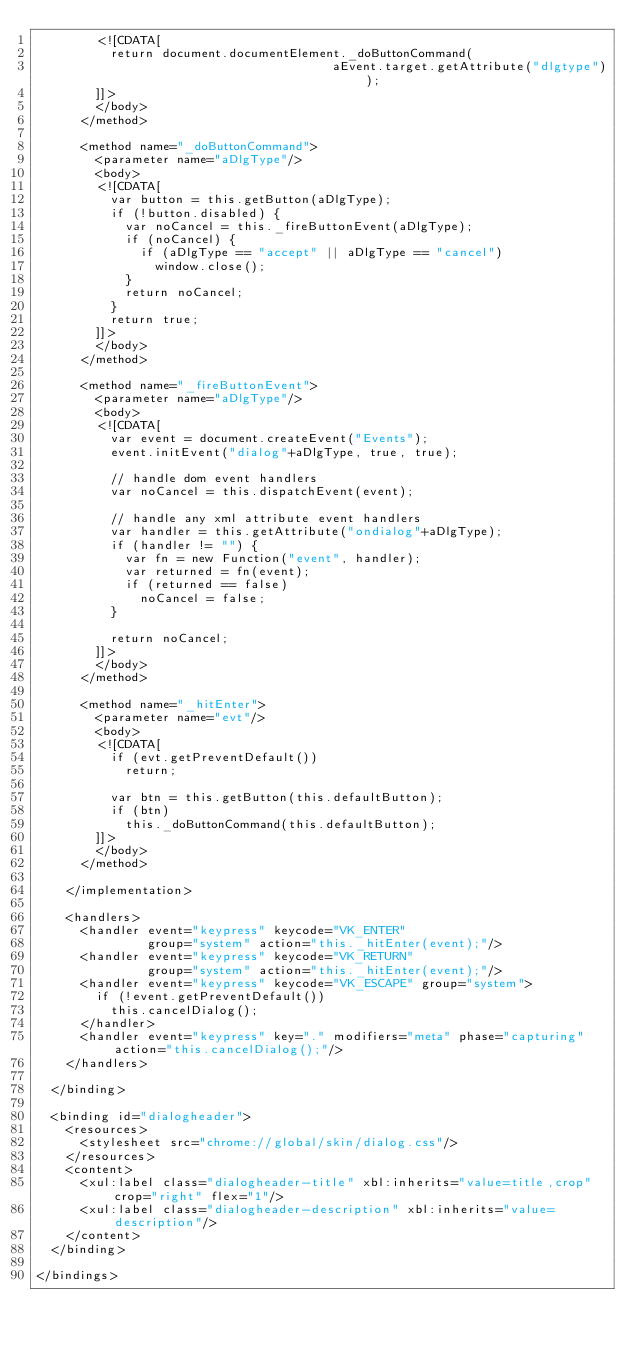Convert code to text. <code><loc_0><loc_0><loc_500><loc_500><_XML_>        <![CDATA[
          return document.documentElement._doButtonCommand(
                                        aEvent.target.getAttribute("dlgtype"));
        ]]>
        </body>
      </method>
      
      <method name="_doButtonCommand">
        <parameter name="aDlgType"/>
        <body>
        <![CDATA[
          var button = this.getButton(aDlgType);
          if (!button.disabled) {
            var noCancel = this._fireButtonEvent(aDlgType);
            if (noCancel) {
              if (aDlgType == "accept" || aDlgType == "cancel")
                window.close();
            }
            return noCancel;
          }
          return true;
        ]]>
        </body>
      </method>
      
      <method name="_fireButtonEvent">
        <parameter name="aDlgType"/>
        <body>
        <![CDATA[
          var event = document.createEvent("Events");
          event.initEvent("dialog"+aDlgType, true, true);
          
          // handle dom event handlers
          var noCancel = this.dispatchEvent(event);
          
          // handle any xml attribute event handlers
          var handler = this.getAttribute("ondialog"+aDlgType);
          if (handler != "") {
            var fn = new Function("event", handler);
            var returned = fn(event);
            if (returned == false)
              noCancel = false;
          }
          
          return noCancel;
        ]]>
        </body>
      </method>

      <method name="_hitEnter">
        <parameter name="evt"/>
        <body>
        <![CDATA[
          if (evt.getPreventDefault())
            return;

          var btn = this.getButton(this.defaultButton);
          if (btn)
            this._doButtonCommand(this.defaultButton);
        ]]>
        </body>
      </method>

    </implementation>
    
    <handlers>
      <handler event="keypress" keycode="VK_ENTER"
               group="system" action="this._hitEnter(event);"/>
      <handler event="keypress" keycode="VK_RETURN"
               group="system" action="this._hitEnter(event);"/>
      <handler event="keypress" keycode="VK_ESCAPE" group="system">
        if (!event.getPreventDefault())
          this.cancelDialog();
      </handler>
      <handler event="keypress" key="." modifiers="meta" phase="capturing" action="this.cancelDialog();"/>
    </handlers>

  </binding>

  <binding id="dialogheader">
    <resources>
      <stylesheet src="chrome://global/skin/dialog.css"/>
    </resources>
    <content>
      <xul:label class="dialogheader-title" xbl:inherits="value=title,crop" crop="right" flex="1"/>
      <xul:label class="dialogheader-description" xbl:inherits="value=description"/>
    </content>
  </binding>

</bindings>
</code> 